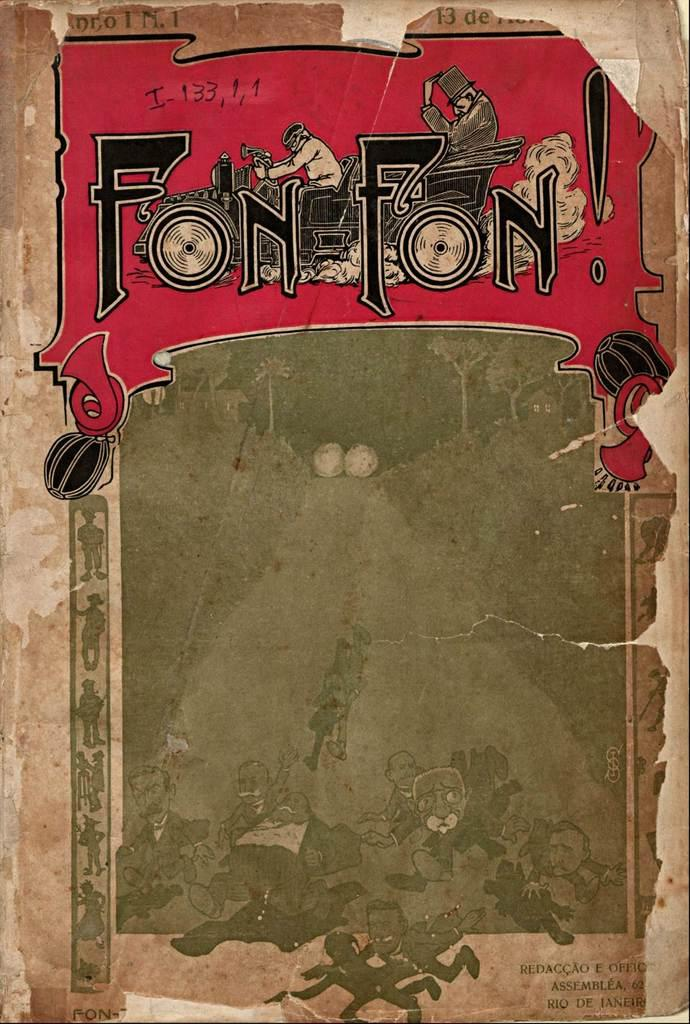<image>
Create a compact narrative representing the image presented. An old sign with Fon Fon at the top 